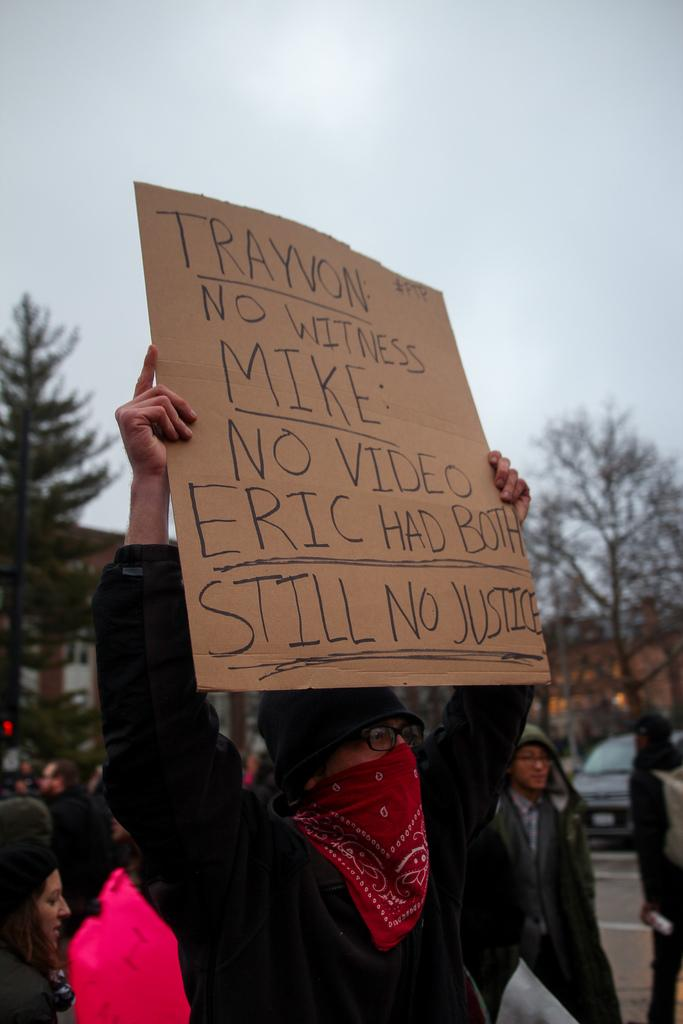What are the people in the image doing? People are protesting on the road. What is the man holding in the image? The man is holding a sheet with text written on it. What can be seen in the background of the image? There are trees, a car, and the sky visible in the background. How much money is being exchanged between the protesters in the image? There is no indication of money being exchanged in the image; people are protesting with a sheet and on the road. What type of baseball equipment can be seen in the image? There is no baseball equipment present in the image. 